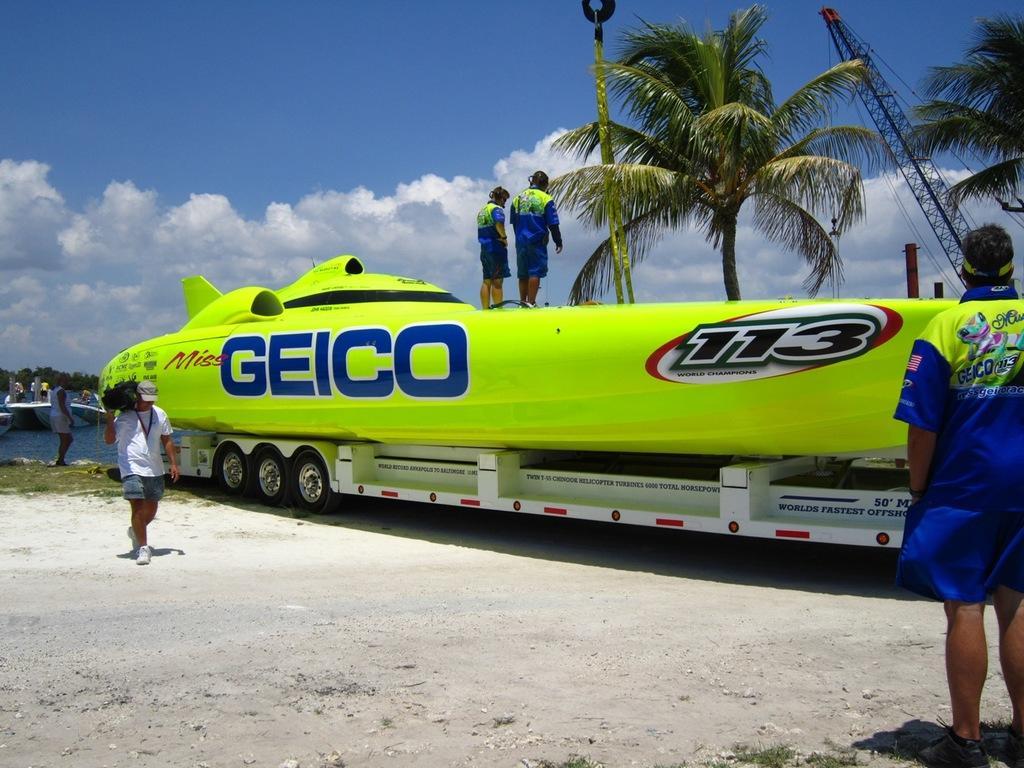Describe this image in one or two sentences. In this image there is a vehicle on the ground. There are numbers and text on the vehicle. There are two persons standing on the vehicle. Behind the vehicle there are trees. To the left there is a man walking on the ground. He is holding an object in his hand. To the extreme right there is another person standing. In the background there is the water and trees. There are boats on the water. At the top there is the sky. 